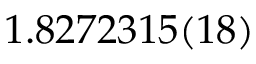<formula> <loc_0><loc_0><loc_500><loc_500>1 . 8 2 7 2 3 1 5 ( 1 8 )</formula> 